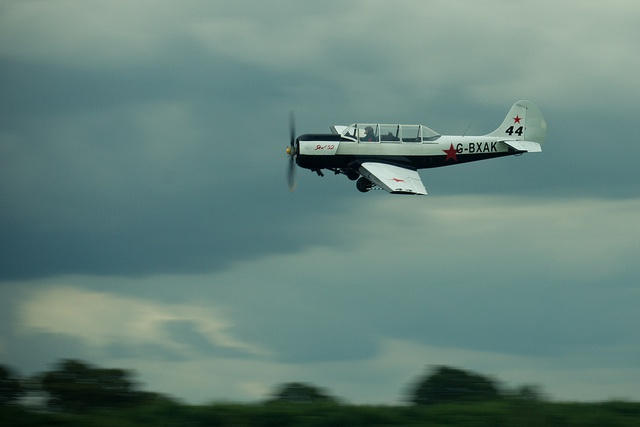Describe the objects in this image and their specific colors. I can see airplane in gray, black, darkgray, and lightgray tones and people in gray, purple, and darkblue tones in this image. 